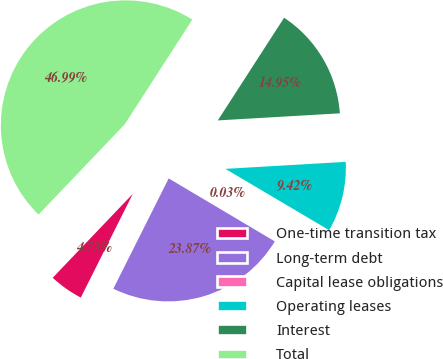Convert chart to OTSL. <chart><loc_0><loc_0><loc_500><loc_500><pie_chart><fcel>One-time transition tax<fcel>Long-term debt<fcel>Capital lease obligations<fcel>Operating leases<fcel>Interest<fcel>Total<nl><fcel>4.73%<fcel>23.87%<fcel>0.03%<fcel>9.42%<fcel>14.95%<fcel>46.99%<nl></chart> 